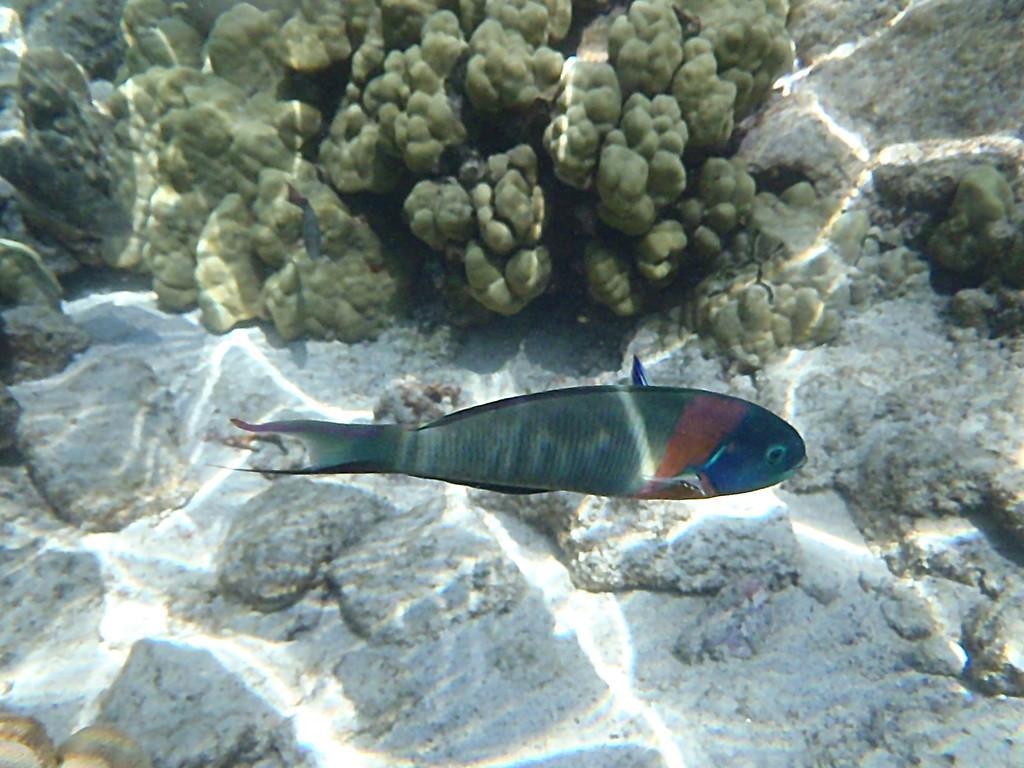In one or two sentences, can you explain what this image depicts? In the image we can see water. In the water there is a fish. 